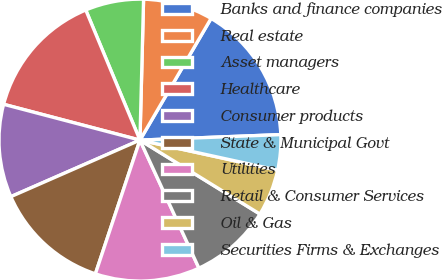Convert chart to OTSL. <chart><loc_0><loc_0><loc_500><loc_500><pie_chart><fcel>Banks and finance companies<fcel>Real estate<fcel>Asset managers<fcel>Healthcare<fcel>Consumer products<fcel>State & Municipal Govt<fcel>Utilities<fcel>Retail & Consumer Services<fcel>Oil & Gas<fcel>Securities Firms & Exchanges<nl><fcel>15.96%<fcel>8.01%<fcel>6.69%<fcel>14.63%<fcel>10.66%<fcel>13.31%<fcel>11.99%<fcel>9.34%<fcel>5.37%<fcel>4.04%<nl></chart> 